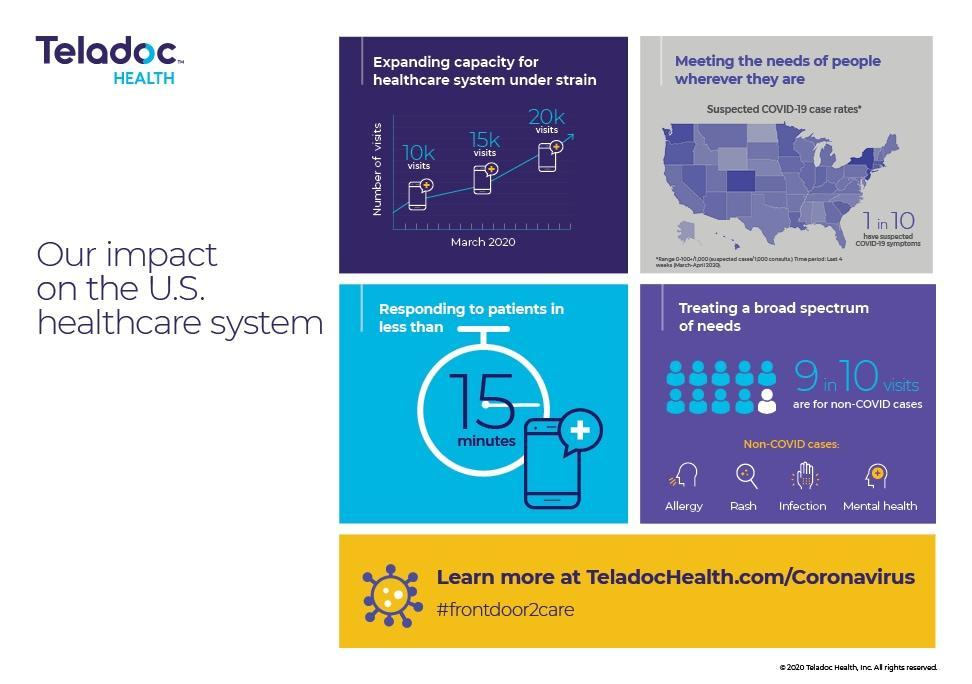Out of 10, how many are not suspected of covid-19 symptoms?
Answer the question with a short phrase. 9 Out of 10, how many are covid cases? 1 Out of 10, how many are non-covid cases? 9 What is the total number of visits in march? 45k 